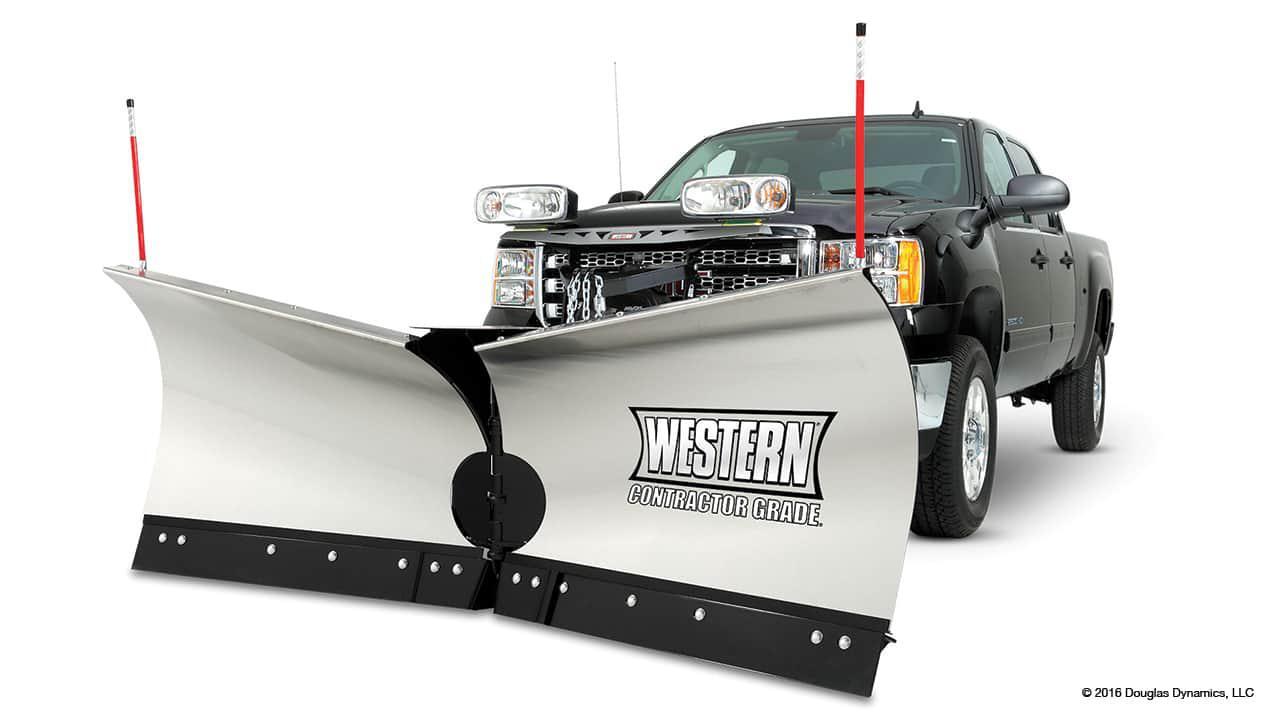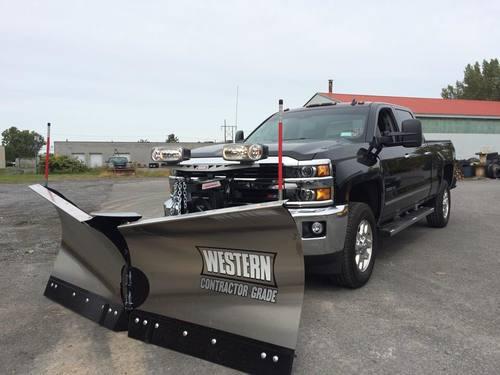The first image is the image on the left, the second image is the image on the right. Assess this claim about the two images: "the trucks on are gray pavement in one of the images.". Correct or not? Answer yes or no. Yes. The first image is the image on the left, the second image is the image on the right. Examine the images to the left and right. Is the description "At least one truck is pushing snow." accurate? Answer yes or no. No. 